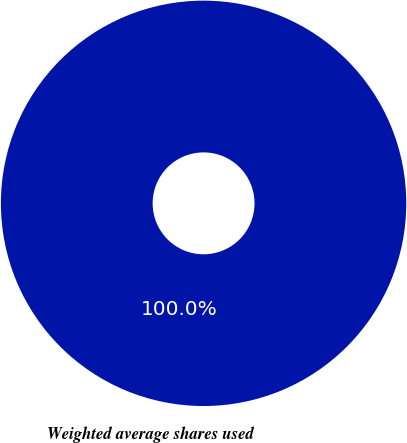<chart> <loc_0><loc_0><loc_500><loc_500><pie_chart><fcel>Weighted average shares used<nl><fcel>100.0%<nl></chart> 